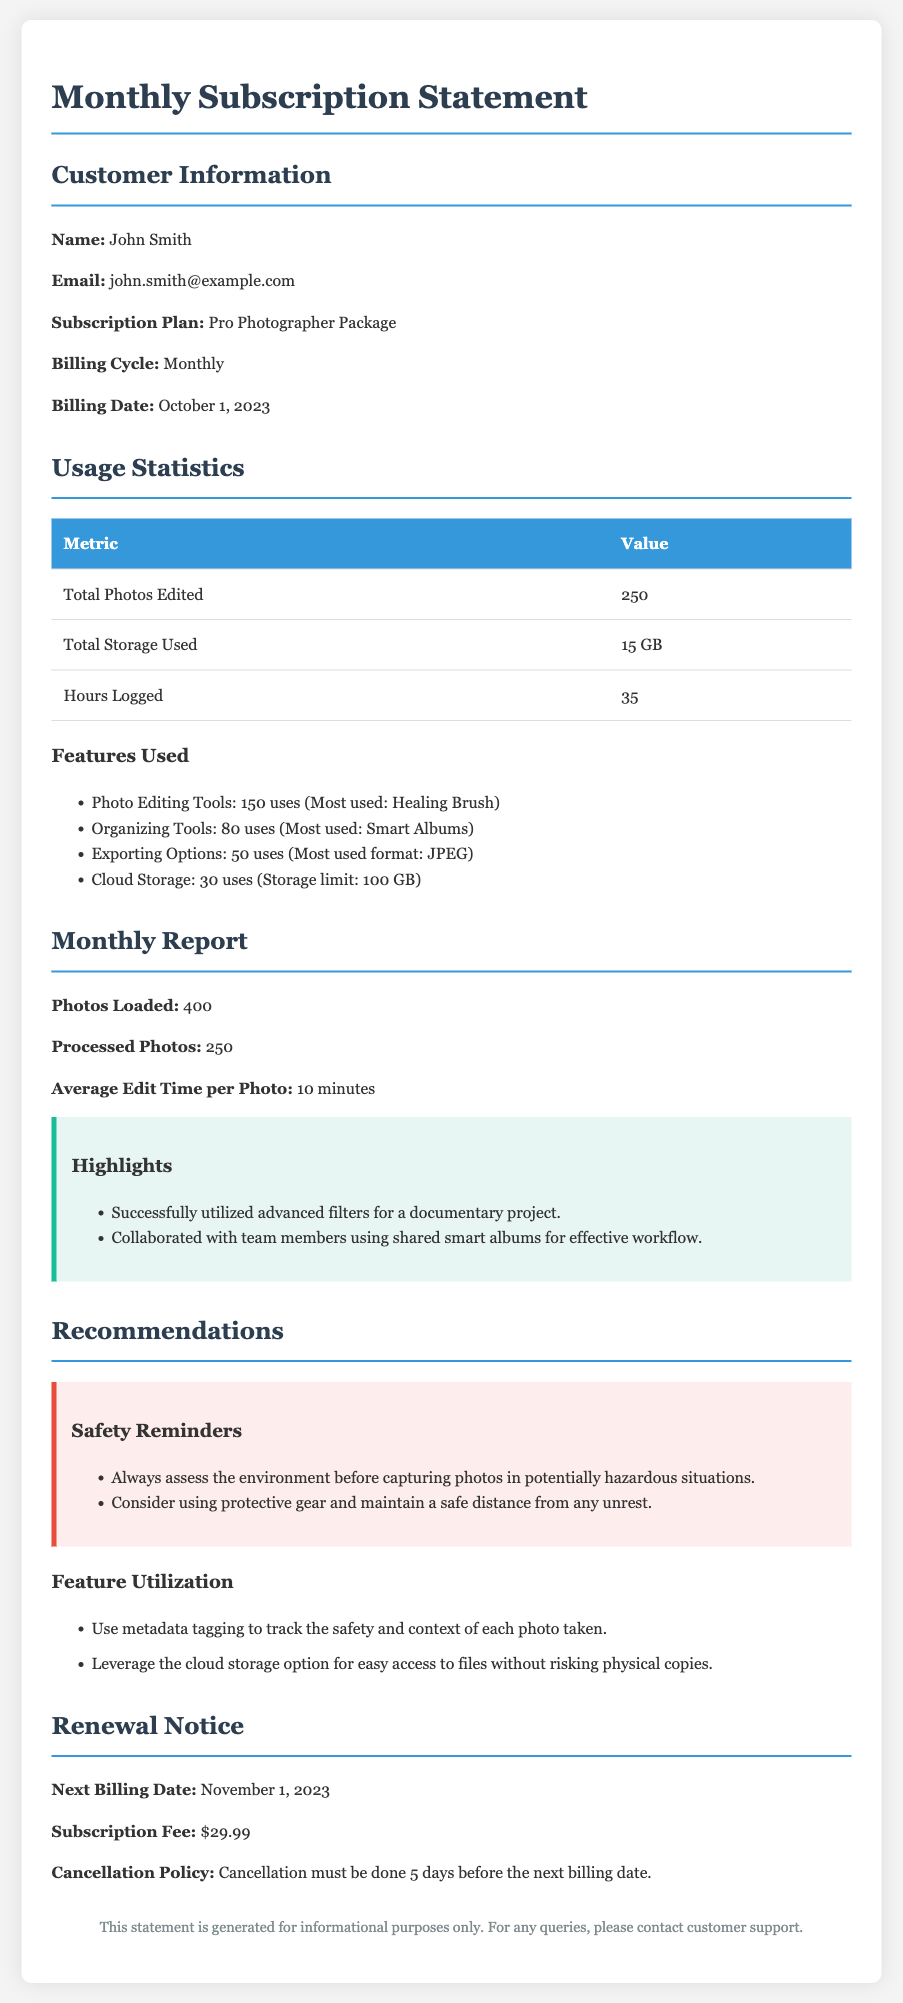what is the customer's name? The customer's name is provided in the customer information section of the document.
Answer: John Smith what is the subscription plan? The subscription plan is specified under the customer information section.
Answer: Pro Photographer Package how many total photos were edited? The total number of photos edited is stated in the usage statistics section.
Answer: 250 what is the average edit time per photo? The average edit time per photo is included in the monthly report section.
Answer: 10 minutes what is the next billing date? The next billing date is mentioned in the renewal notice section.
Answer: November 1, 2023 how many hours were logged? The hours logged are detailed in the usage statistics section of the document.
Answer: 35 what feature was most used for photo editing? The most used feature for photo editing is called out in the usage statistics section.
Answer: Healing Brush what is the storage limit for cloud storage? The storage limit for cloud storage is specified in the features used section.
Answer: 100 GB what is the cancellation policy? The cancellation policy is described in the renewal notice section.
Answer: Cancellation must be done 5 days before the next billing date 